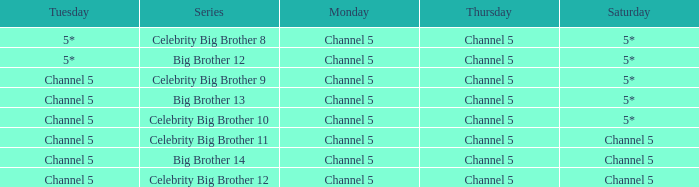Which Tuesday does big brother 12 air? 5*. 